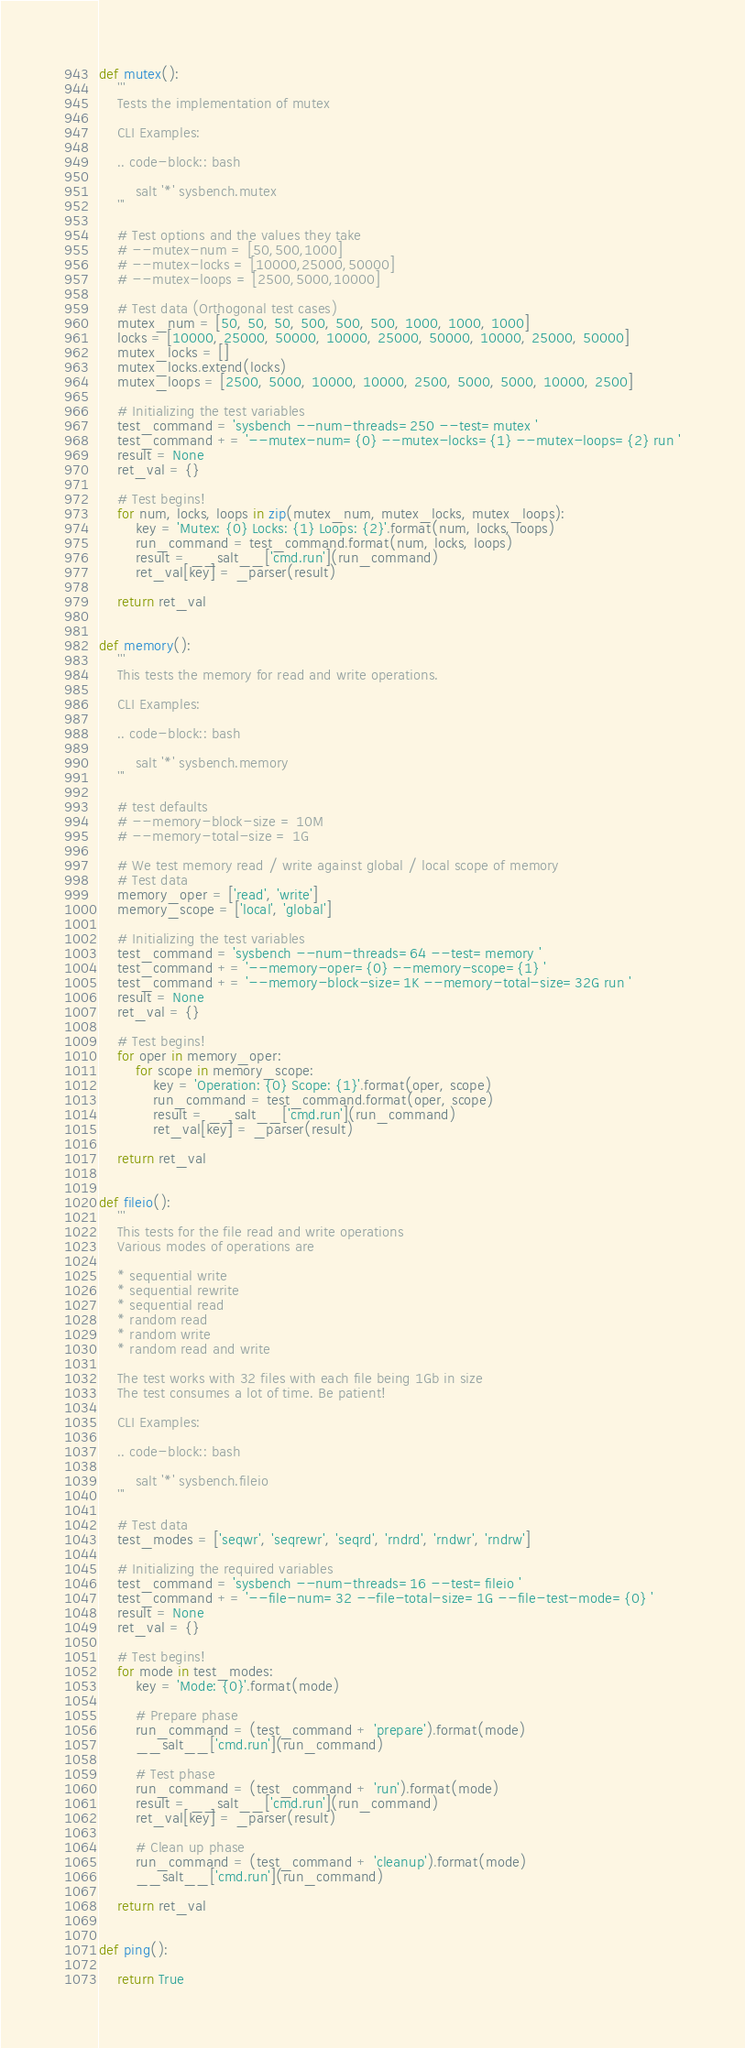<code> <loc_0><loc_0><loc_500><loc_500><_Python_>

def mutex():
    '''
    Tests the implementation of mutex

    CLI Examples:

    .. code-block:: bash

        salt '*' sysbench.mutex
    '''

    # Test options and the values they take
    # --mutex-num = [50,500,1000]
    # --mutex-locks = [10000,25000,50000]
    # --mutex-loops = [2500,5000,10000]

    # Test data (Orthogonal test cases)
    mutex_num = [50, 50, 50, 500, 500, 500, 1000, 1000, 1000]
    locks = [10000, 25000, 50000, 10000, 25000, 50000, 10000, 25000, 50000]
    mutex_locks = []
    mutex_locks.extend(locks)
    mutex_loops = [2500, 5000, 10000, 10000, 2500, 5000, 5000, 10000, 2500]

    # Initializing the test variables
    test_command = 'sysbench --num-threads=250 --test=mutex '
    test_command += '--mutex-num={0} --mutex-locks={1} --mutex-loops={2} run '
    result = None
    ret_val = {}

    # Test begins!
    for num, locks, loops in zip(mutex_num, mutex_locks, mutex_loops):
        key = 'Mutex: {0} Locks: {1} Loops: {2}'.format(num, locks, loops)
        run_command = test_command.format(num, locks, loops)
        result = __salt__['cmd.run'](run_command)
        ret_val[key] = _parser(result)

    return ret_val


def memory():
    '''
    This tests the memory for read and write operations.

    CLI Examples:

    .. code-block:: bash

        salt '*' sysbench.memory
    '''

    # test defaults
    # --memory-block-size = 10M
    # --memory-total-size = 1G

    # We test memory read / write against global / local scope of memory
    # Test data
    memory_oper = ['read', 'write']
    memory_scope = ['local', 'global']

    # Initializing the test variables
    test_command = 'sysbench --num-threads=64 --test=memory '
    test_command += '--memory-oper={0} --memory-scope={1} '
    test_command += '--memory-block-size=1K --memory-total-size=32G run '
    result = None
    ret_val = {}

    # Test begins!
    for oper in memory_oper:
        for scope in memory_scope:
            key = 'Operation: {0} Scope: {1}'.format(oper, scope)
            run_command = test_command.format(oper, scope)
            result = __salt__['cmd.run'](run_command)
            ret_val[key] = _parser(result)

    return ret_val


def fileio():
    '''
    This tests for the file read and write operations
    Various modes of operations are

    * sequential write
    * sequential rewrite
    * sequential read
    * random read
    * random write
    * random read and write

    The test works with 32 files with each file being 1Gb in size
    The test consumes a lot of time. Be patient!

    CLI Examples:

    .. code-block:: bash

        salt '*' sysbench.fileio
    '''

    # Test data
    test_modes = ['seqwr', 'seqrewr', 'seqrd', 'rndrd', 'rndwr', 'rndrw']

    # Initializing the required variables
    test_command = 'sysbench --num-threads=16 --test=fileio '
    test_command += '--file-num=32 --file-total-size=1G --file-test-mode={0} '
    result = None
    ret_val = {}

    # Test begins!
    for mode in test_modes:
        key = 'Mode: {0}'.format(mode)

        # Prepare phase
        run_command = (test_command + 'prepare').format(mode)
        __salt__['cmd.run'](run_command)

        # Test phase
        run_command = (test_command + 'run').format(mode)
        result = __salt__['cmd.run'](run_command)
        ret_val[key] = _parser(result)

        # Clean up phase
        run_command = (test_command + 'cleanup').format(mode)
        __salt__['cmd.run'](run_command)

    return ret_val


def ping():

    return True
</code> 